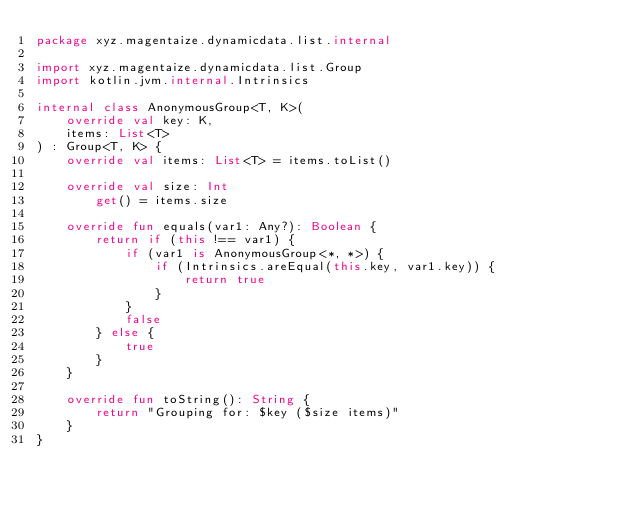<code> <loc_0><loc_0><loc_500><loc_500><_Kotlin_>package xyz.magentaize.dynamicdata.list.internal

import xyz.magentaize.dynamicdata.list.Group
import kotlin.jvm.internal.Intrinsics

internal class AnonymousGroup<T, K>(
    override val key: K,
    items: List<T>
) : Group<T, K> {
    override val items: List<T> = items.toList()

    override val size: Int
        get() = items.size

    override fun equals(var1: Any?): Boolean {
        return if (this !== var1) {
            if (var1 is AnonymousGroup<*, *>) {
                if (Intrinsics.areEqual(this.key, var1.key)) {
                    return true
                }
            }
            false
        } else {
            true
        }
    }

    override fun toString(): String {
        return "Grouping for: $key ($size items)"
    }
}
</code> 